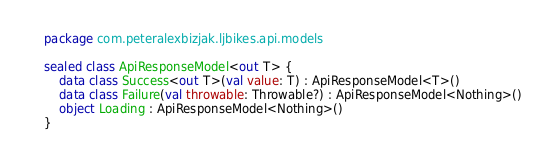Convert code to text. <code><loc_0><loc_0><loc_500><loc_500><_Kotlin_>package com.peteralexbizjak.ljbikes.api.models

sealed class ApiResponseModel<out T> {
    data class Success<out T>(val value: T) : ApiResponseModel<T>()
    data class Failure(val throwable: Throwable?) : ApiResponseModel<Nothing>()
    object Loading : ApiResponseModel<Nothing>()
}</code> 